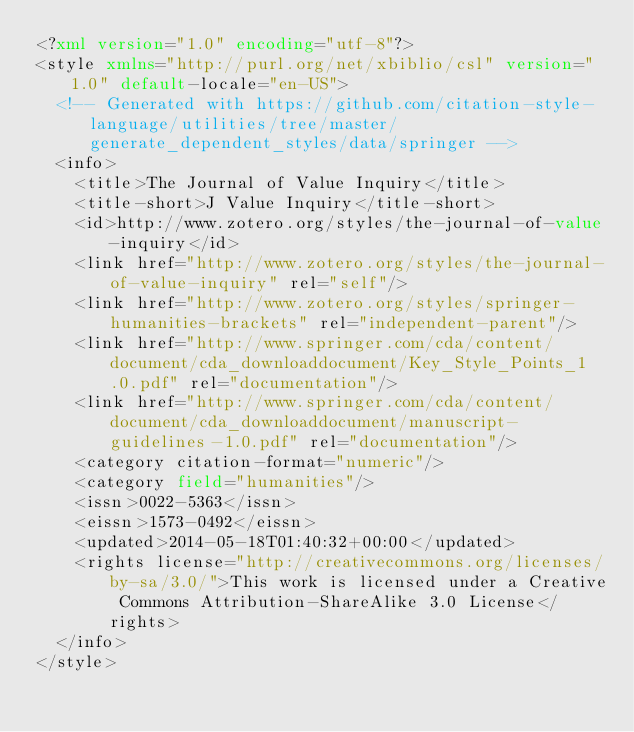<code> <loc_0><loc_0><loc_500><loc_500><_XML_><?xml version="1.0" encoding="utf-8"?>
<style xmlns="http://purl.org/net/xbiblio/csl" version="1.0" default-locale="en-US">
  <!-- Generated with https://github.com/citation-style-language/utilities/tree/master/generate_dependent_styles/data/springer -->
  <info>
    <title>The Journal of Value Inquiry</title>
    <title-short>J Value Inquiry</title-short>
    <id>http://www.zotero.org/styles/the-journal-of-value-inquiry</id>
    <link href="http://www.zotero.org/styles/the-journal-of-value-inquiry" rel="self"/>
    <link href="http://www.zotero.org/styles/springer-humanities-brackets" rel="independent-parent"/>
    <link href="http://www.springer.com/cda/content/document/cda_downloaddocument/Key_Style_Points_1.0.pdf" rel="documentation"/>
    <link href="http://www.springer.com/cda/content/document/cda_downloaddocument/manuscript-guidelines-1.0.pdf" rel="documentation"/>
    <category citation-format="numeric"/>
    <category field="humanities"/>
    <issn>0022-5363</issn>
    <eissn>1573-0492</eissn>
    <updated>2014-05-18T01:40:32+00:00</updated>
    <rights license="http://creativecommons.org/licenses/by-sa/3.0/">This work is licensed under a Creative Commons Attribution-ShareAlike 3.0 License</rights>
  </info>
</style>
</code> 